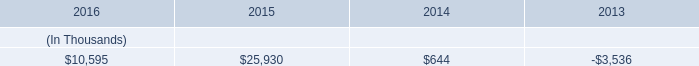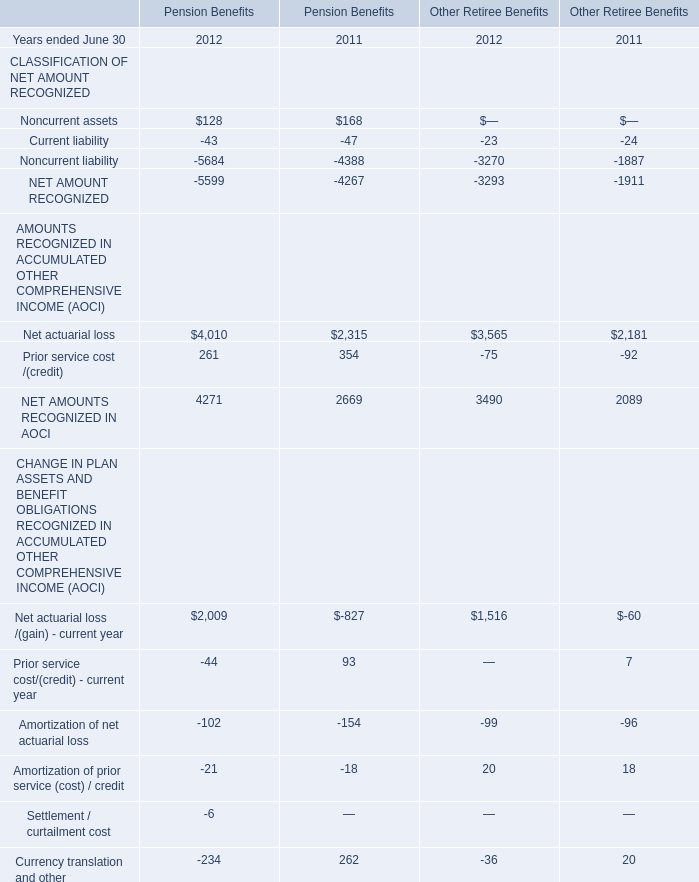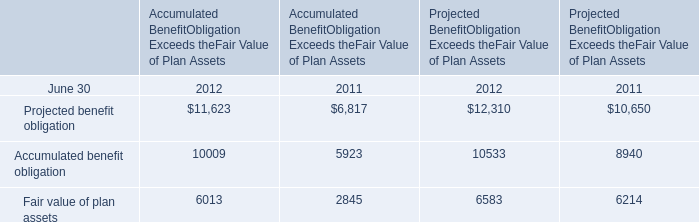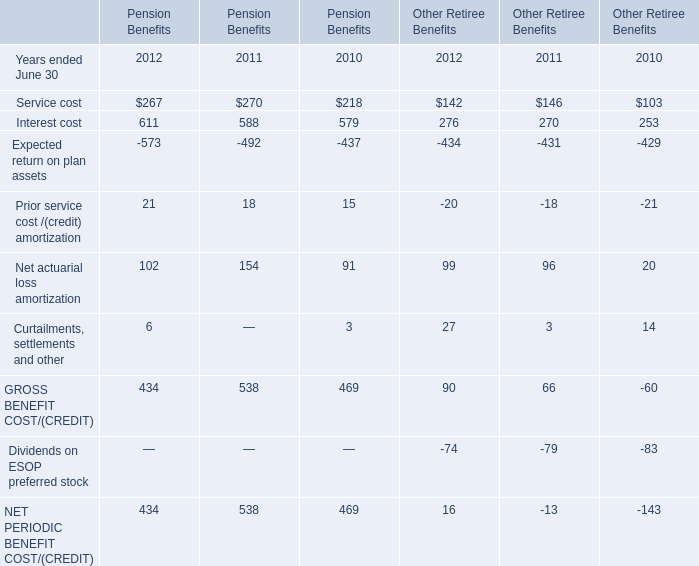What is the difference between the greatest Service cost in 2012 and 2011? 
Computations: (270 - 267)
Answer: 3.0. 